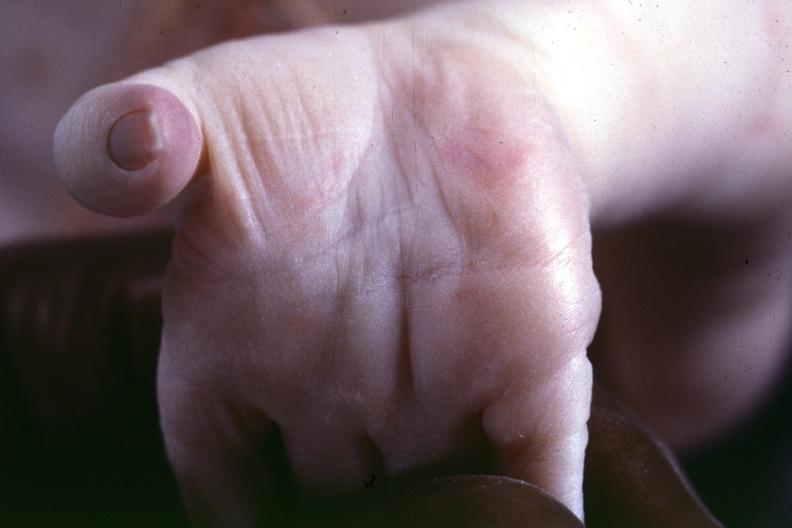s acute lymphocytic leukemia indicated?
Answer the question using a single word or phrase. No 